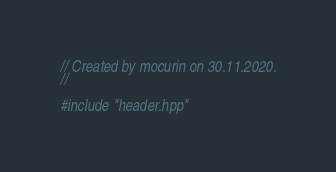Convert code to text. <code><loc_0><loc_0><loc_500><loc_500><_C++_>// Created by mocurin on 30.11.2020.
//

#include "header.hpp"</code> 